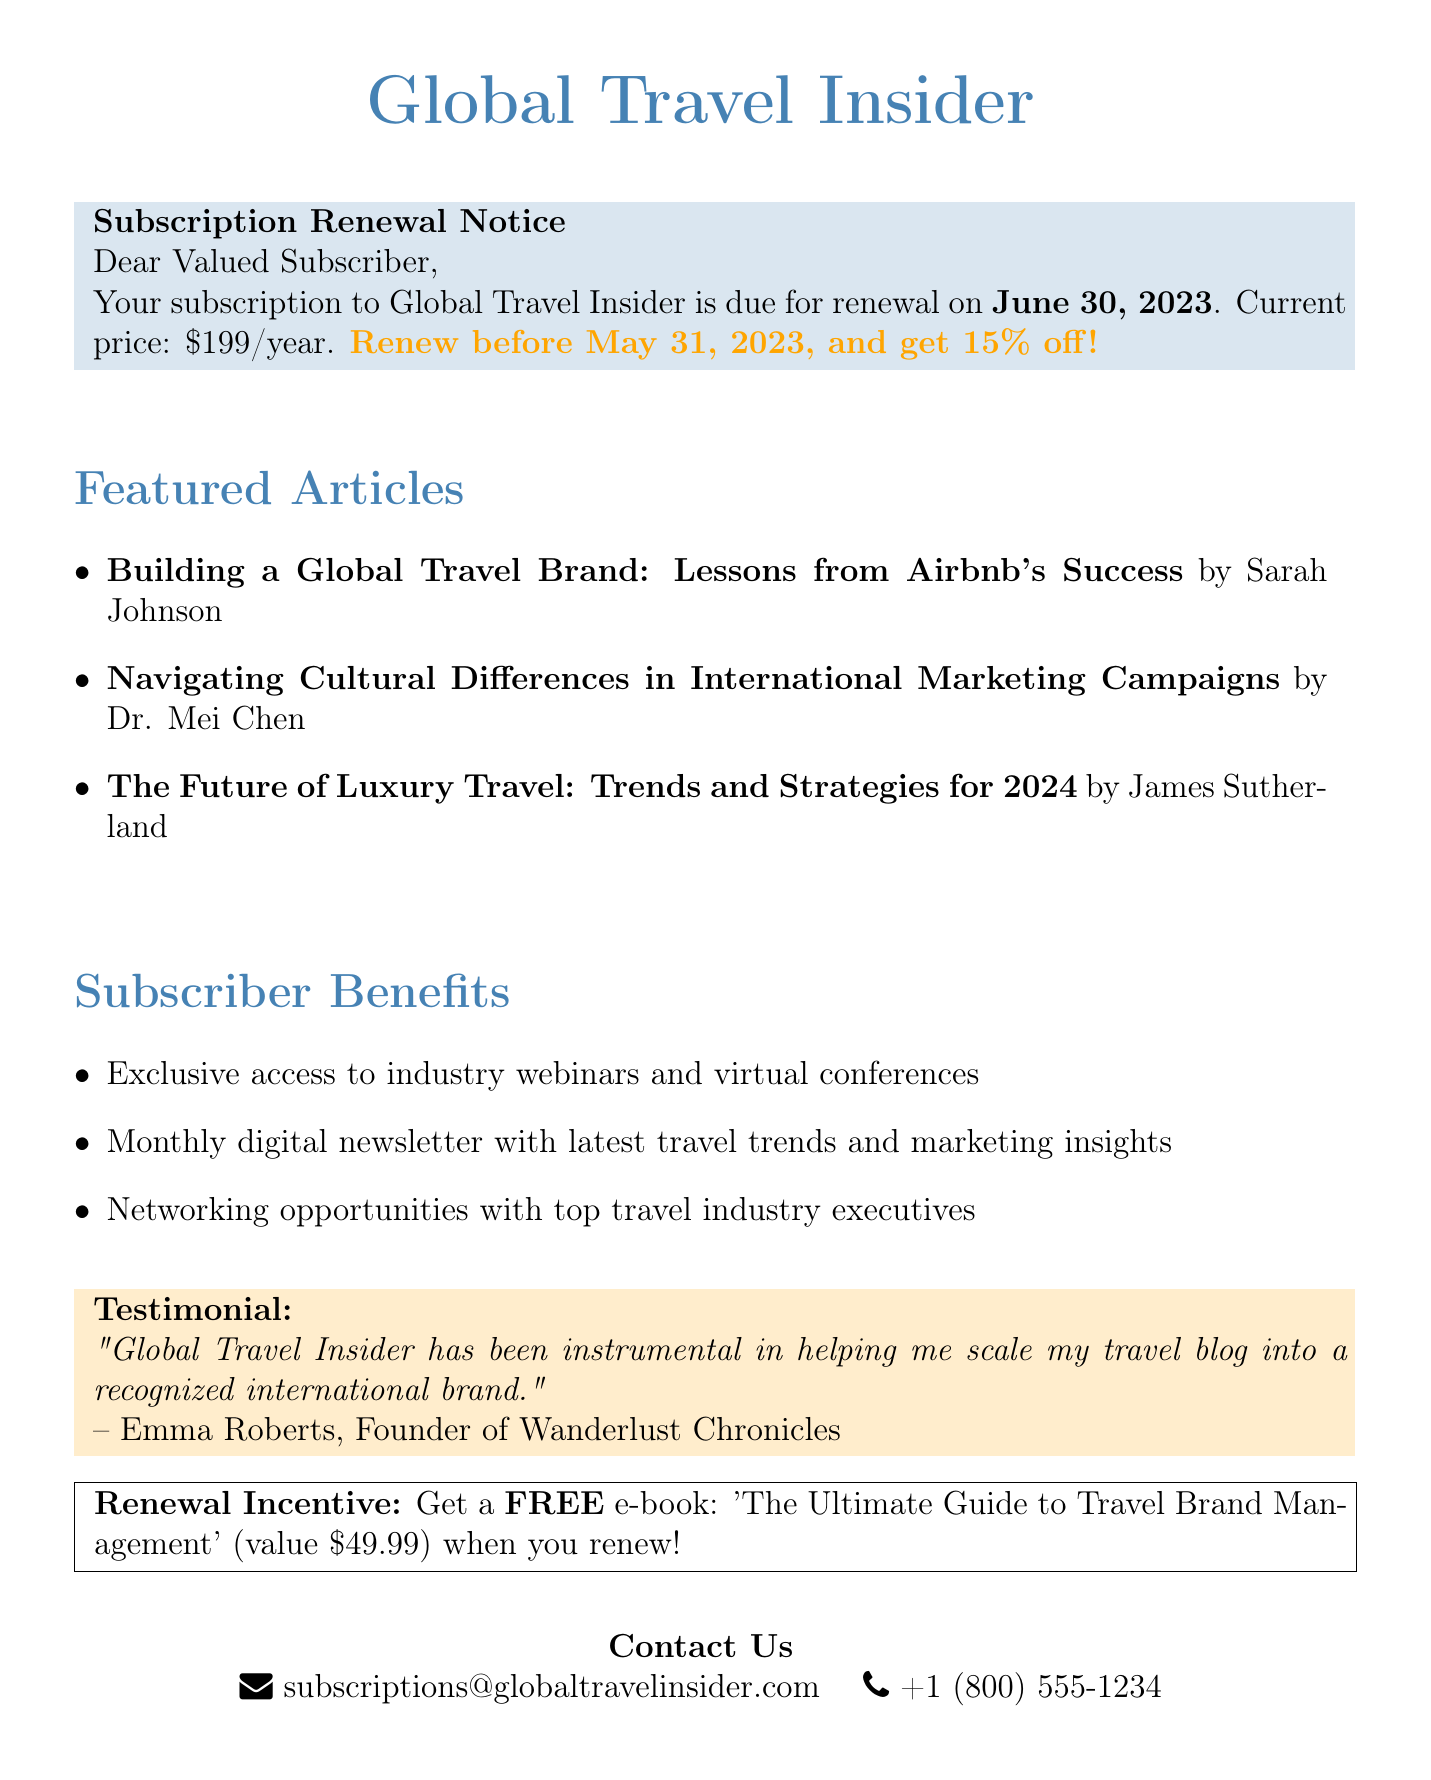what is the magazine name? The magazine name is mentioned at the beginning of the document as Global Travel Insider.
Answer: Global Travel Insider what is the renewal date? The renewal date is specified in the subscription details section.
Answer: June 30, 2023 what is the current price of the subscription? The current price is stated clearly in the document.
Answer: $199/year what discount is offered for early renewal? The document provides information about the early renewal discount.
Answer: 15% off if renewed before May 31, 2023 who is the author of the article "Building a Global Travel Brand"? The author is listed under the featured articles section.
Answer: Sarah Johnson what is one benefit of being a subscriber? Several benefits are listed, and any of them could be valid answers.
Answer: Exclusive access to industry webinars and virtual conferences what can subscribers receive as a renewal incentive? The renewal incentive is described in a specific section of the document.
Answer: Free e-book: 'The Ultimate Guide to Travel Brand Management' what is the value of the free e-book? The value of the e-book is mentioned in the renewal incentive section.
Answer: $49.99 what is the testimonial source? The testimonial provides the name of the individual who authored it.
Answer: Emma Roberts, Founder of Wanderlust Chronicles 